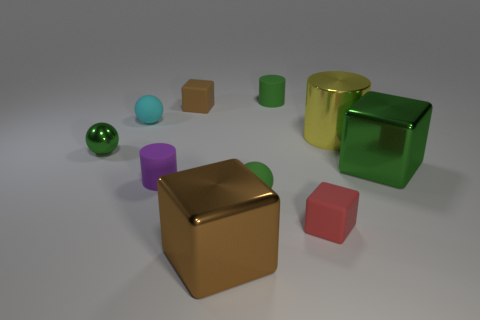Subtract all green cylinders. How many brown cubes are left? 2 Subtract 1 cylinders. How many cylinders are left? 2 Subtract all small cylinders. How many cylinders are left? 1 Subtract all green cubes. How many cubes are left? 3 Subtract all cyan cubes. Subtract all green cylinders. How many cubes are left? 4 Subtract all spheres. How many objects are left? 7 Subtract all big brown cubes. Subtract all tiny cyan shiny cylinders. How many objects are left? 9 Add 5 small green rubber balls. How many small green rubber balls are left? 6 Add 10 purple rubber balls. How many purple rubber balls exist? 10 Subtract 0 cyan cubes. How many objects are left? 10 